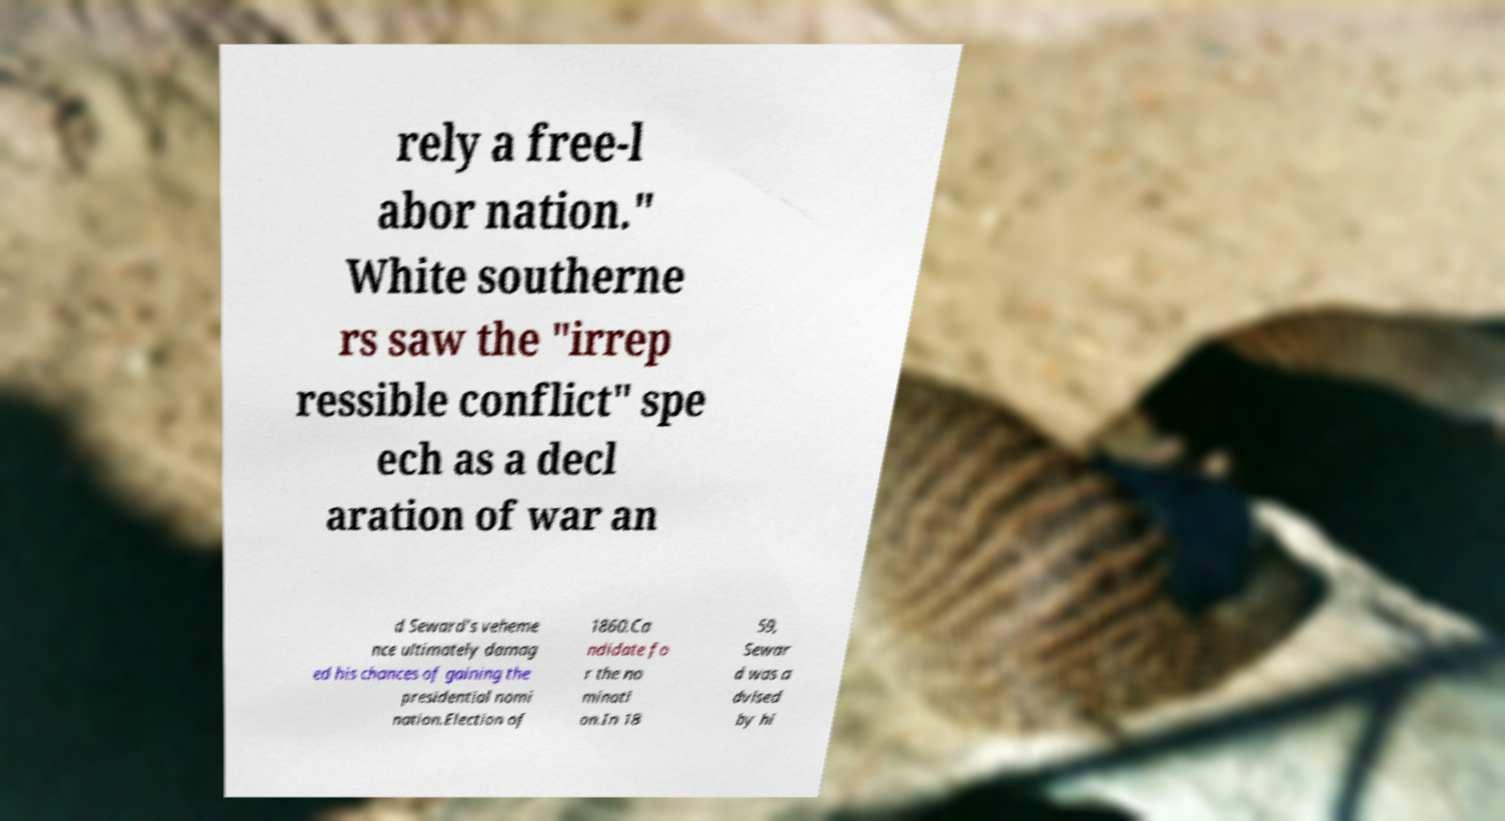I need the written content from this picture converted into text. Can you do that? rely a free-l abor nation." White southerne rs saw the "irrep ressible conflict" spe ech as a decl aration of war an d Seward's veheme nce ultimately damag ed his chances of gaining the presidential nomi nation.Election of 1860.Ca ndidate fo r the no minati on.In 18 59, Sewar d was a dvised by hi 